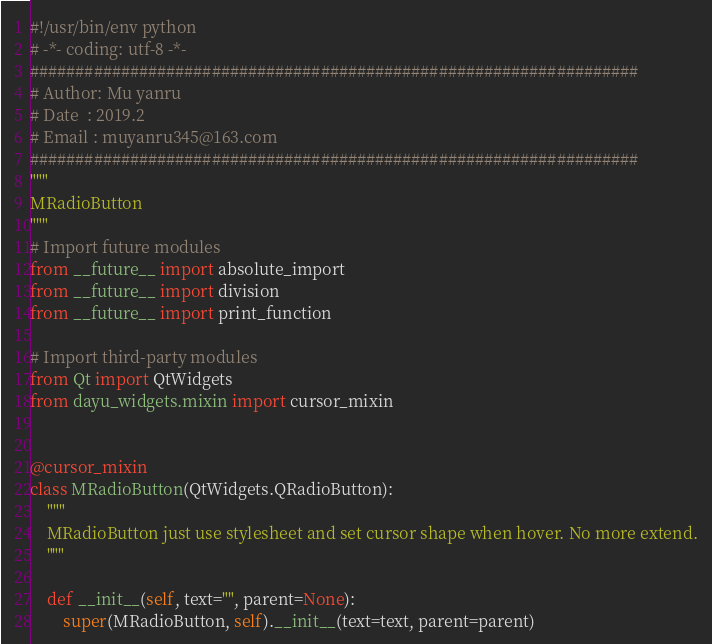<code> <loc_0><loc_0><loc_500><loc_500><_Python_>#!/usr/bin/env python
# -*- coding: utf-8 -*-
###################################################################
# Author: Mu yanru
# Date  : 2019.2
# Email : muyanru345@163.com
###################################################################
"""
MRadioButton
"""
# Import future modules
from __future__ import absolute_import
from __future__ import division
from __future__ import print_function

# Import third-party modules
from Qt import QtWidgets
from dayu_widgets.mixin import cursor_mixin


@cursor_mixin
class MRadioButton(QtWidgets.QRadioButton):
    """
    MRadioButton just use stylesheet and set cursor shape when hover. No more extend.
    """

    def __init__(self, text="", parent=None):
        super(MRadioButton, self).__init__(text=text, parent=parent)
</code> 